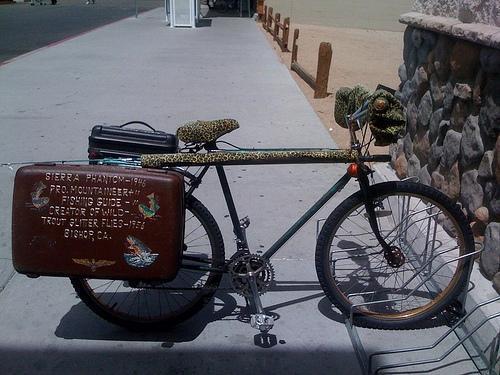How many suitcases are there?
Give a very brief answer. 2. How many horses with a white stomach are there?
Give a very brief answer. 0. 